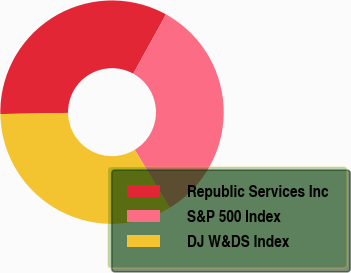Convert chart. <chart><loc_0><loc_0><loc_500><loc_500><pie_chart><fcel>Republic Services Inc<fcel>S&P 500 Index<fcel>DJ W&DS Index<nl><fcel>33.3%<fcel>33.33%<fcel>33.37%<nl></chart> 